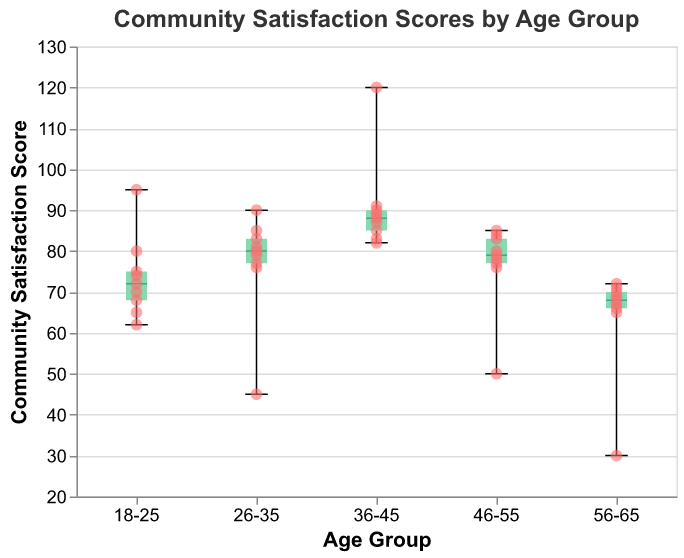What's the median satisfaction score for the 26-35 age group? The box plot shows the median as a straight line inside the box. For the 26-35 age group, the median line is at 80.
Answer: 80 What are the minimum and maximum satisfaction scores for the 36-45 age group? The points at the bottom and top of the whiskers in the box plot represent the minimum and maximum values. For the 36-45 age group, the minimum is around 82, and the maximum is 120.
Answer: 82 and 120 Which age group has the highest outlier? An outlier is displayed as a point outside the whiskers of the box plot. For the 36-45 age group, there is an outlier at 120, which is higher than any outlier in other age groups.
Answer: 36-45 Which age group has the lowest community satisfaction score indicated by an outlier? The lowest community satisfaction score indicated by an outlier point can be found in the 56-65 age group, where there is a point at 30.
Answer: 56-65 In terms of the interquartile range (IQR), which age group shows the greatest spread? The IQR is represented by the height of the box. The 18-25 age group has the largest box, indicating the greatest spread among the middle 50% of the data.
Answer: 18-25 Which age group shows the smallest interquartile range (IQR)? The IQR is the distance between the top and bottom of the box. The 46-55 age group has the smallest box, indicating the smallest spread among the middle 50% of the data.
Answer: 46-55 How many outliers can be found in the 26-35 age group? Outliers are points outside the whiskers. For the 26-35 age group, there is just one outlier at 45.
Answer: 1 Which age group has the highest median satisfaction score? The median is the middle line of the box plot. The 36-45 age group has the highest median satisfaction score, around 87.5.
Answer: 36-45 What is the community satisfaction score range for the 46-55 age group? The range is found from the bottom of the whisker to the top of the whisker. For the 46-55 age group, the range is from 50 to 85.
Answer: 50 to 85 